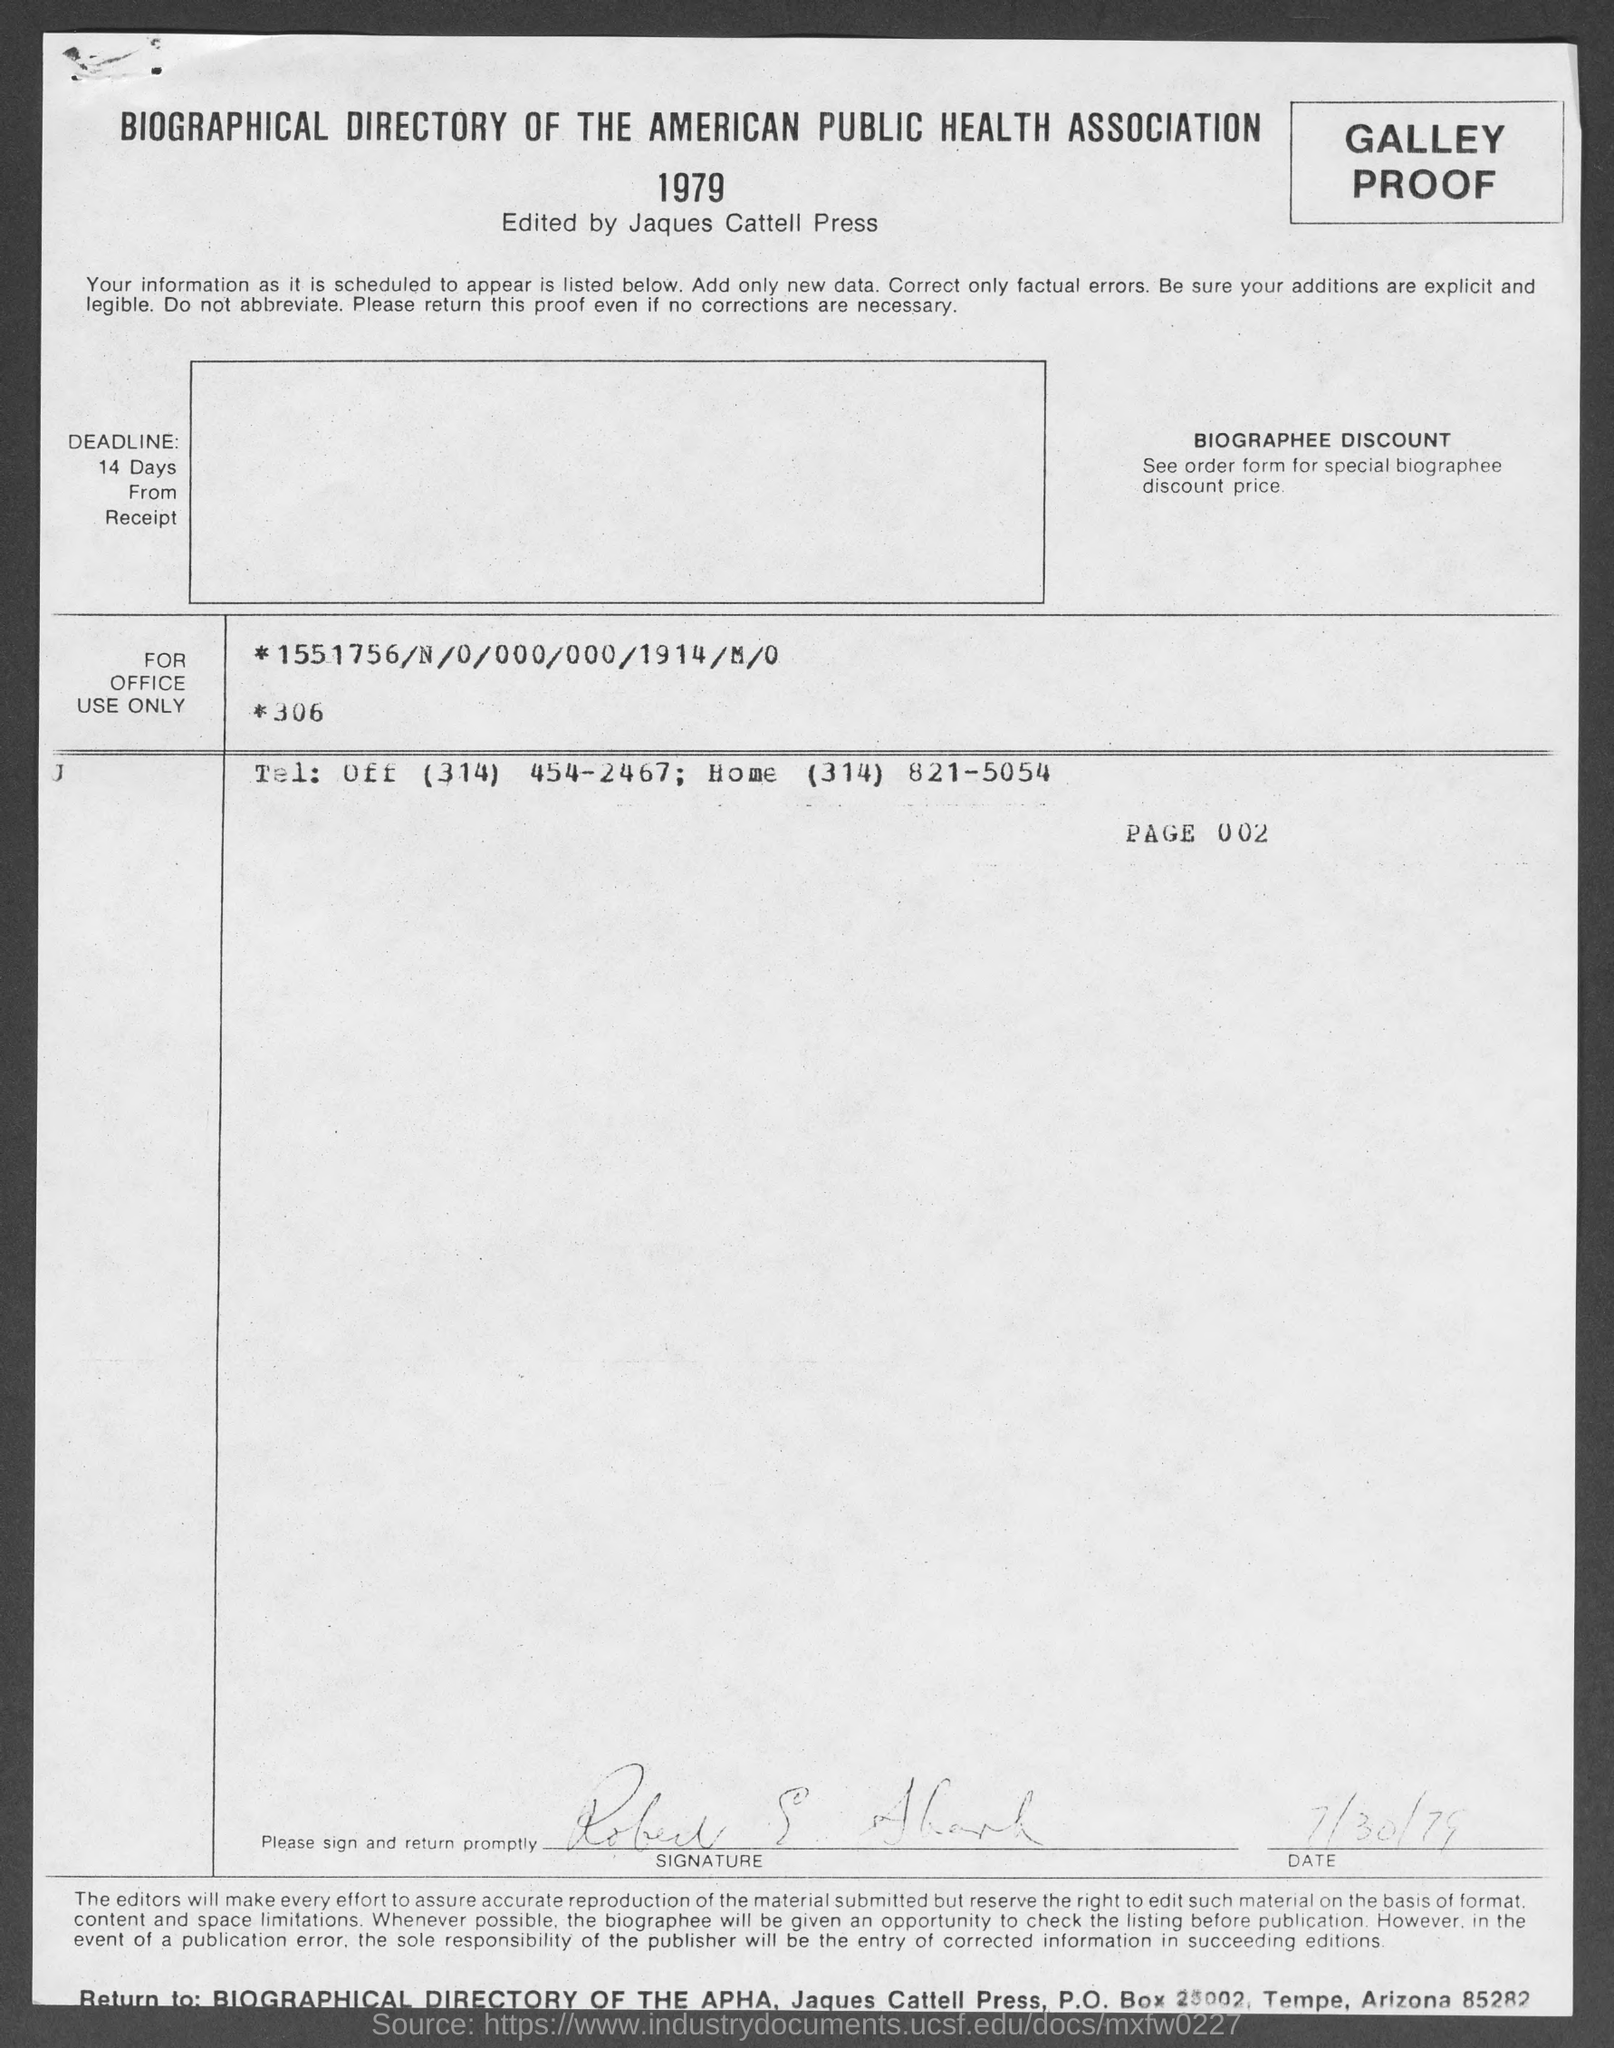Identify some key points in this picture. The date mentioned in this document is July 30, 1979. 